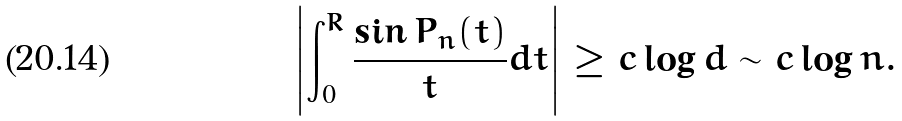<formula> <loc_0><loc_0><loc_500><loc_500>\left | \int _ { 0 } ^ { R } \frac { \sin { P _ { n } ( t ) } } { t } d t \right | \geq c \log d \sim c \log n .</formula> 